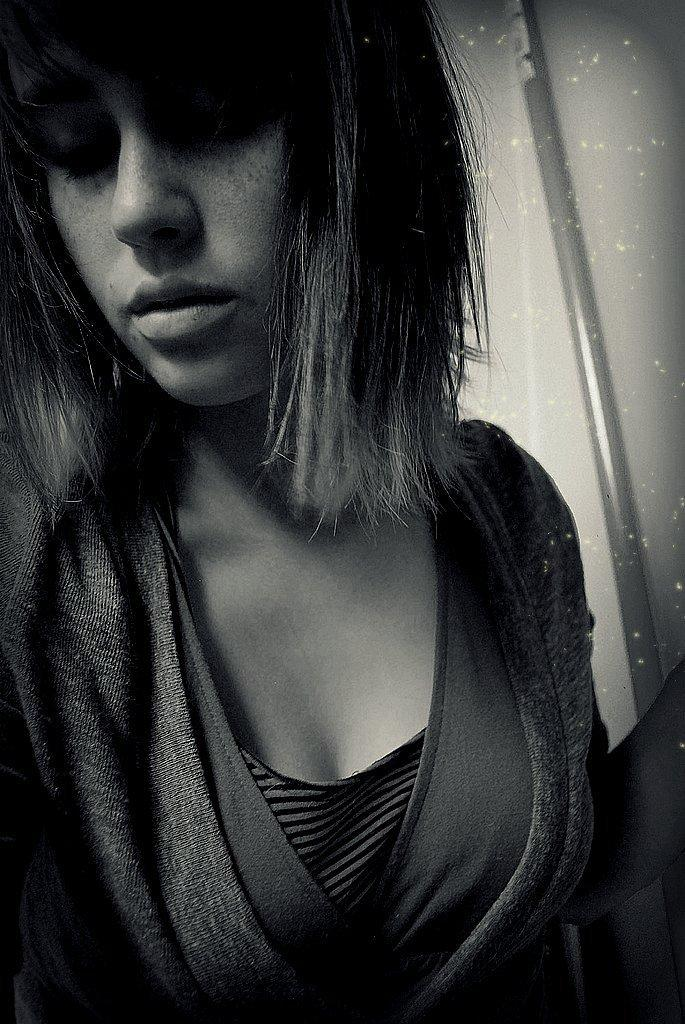What is the color scheme of the image? The image is black and white. Who is present in the image? There is a woman in the image. What is the woman wearing? The woman is wearing a jacket. What can be seen on the right side of the image? There is a metal rod on the right side of the image. How is the metal rod connected to the surroundings? The metal rod is attached to the wall. What type of plantation can be seen in the background of the image? There is no plantation present in the image; it is a black and white image featuring a woman, a jacket, and a metal rod attached to the wall. How many laborers are working in the image? There are no laborers present in the image. 